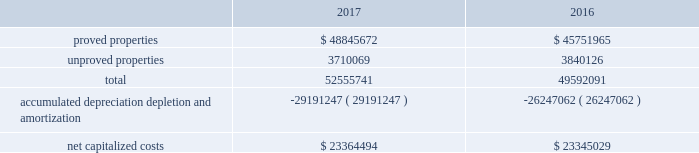Eog resources , inc .
Supplemental information to consolidated financial statements ( continued ) capitalized costs relating to oil and gas producing activities .
The table sets forth the capitalized costs relating to eog's crude oil and natural gas producing activities at december 31 , 2017 and 2016: .
Costs incurred in oil and gas property acquisition , exploration and development activities .
The acquisition , exploration and development costs disclosed in the following tables are in accordance with definitions in the extractive industries - oil and a gas topic of the accounting standards codification ( asc ) .
Acquisition costs include costs incurred to purchase , lease or otherwise acquire property .
Exploration costs include additions to exploratory wells , including those in progress , and exploration expenses .
Development costs include additions to production facilities and equipment and additions to development wells , including those in progress. .
Considering the year 2016 , what is the percentage of unproved properties among the total properties? 
Rationale: it is the capitalized costs related to unproved properties divided by the capitalized costs related to all properties , then turned into a percentage .
Computations: (3840126 / 49592091)
Answer: 0.07743. 